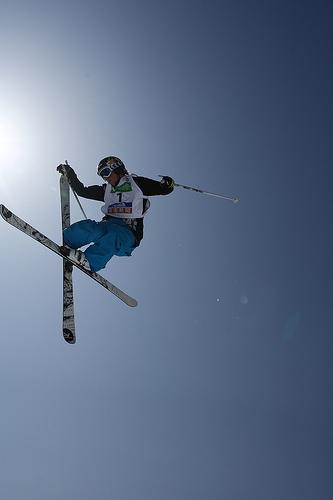What is the boy doing?
Short answer required. Skiing. Is this person close to the sun?
Write a very short answer. No. What color is the sky?
Short answer required. Blue. What letter of the alphabet do the crossed skis appear to make?
Answer briefly. X. IS this a jet?
Answer briefly. No. What color are the skis?
Answer briefly. White. 